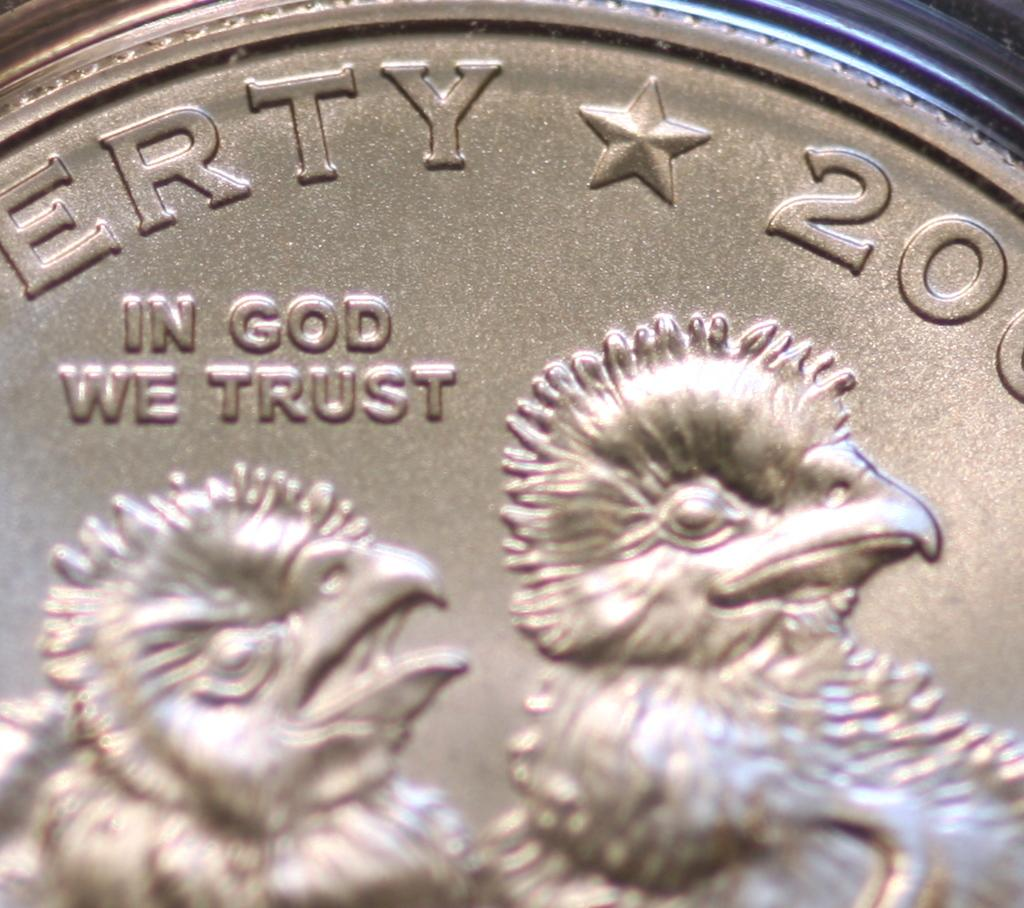<image>
Create a compact narrative representing the image presented. Two baby birds printed on a coin next to the words In God We Trust. 